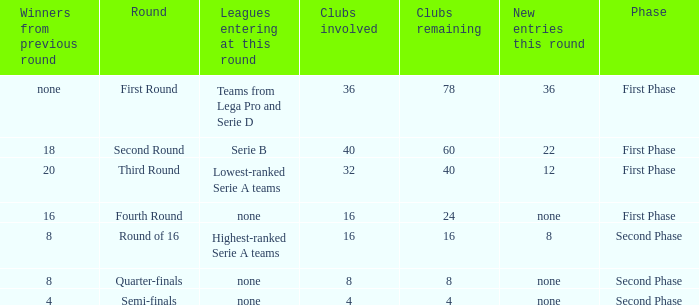When looking at new entries this round and seeing 8; what number in total is there for clubs remaining? 1.0. 